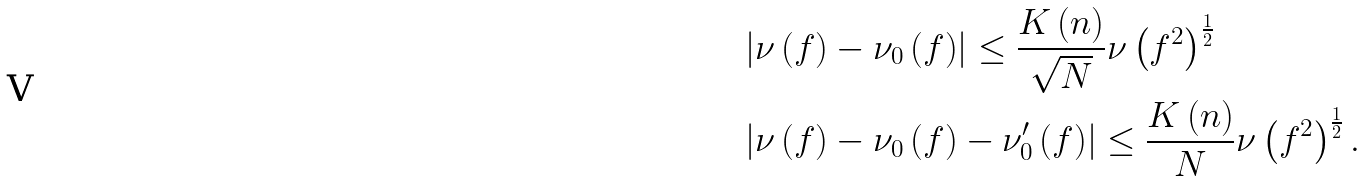<formula> <loc_0><loc_0><loc_500><loc_500>& \left | \nu \left ( f \right ) - \nu _ { 0 } \left ( f \right ) \right | \leq \frac { K \left ( n \right ) } { \sqrt { N } } \nu \left ( f ^ { 2 } \right ) ^ { \frac { 1 } { 2 } } \\ & \left | \nu \left ( f \right ) - \nu _ { 0 } \left ( f \right ) - \nu _ { 0 } ^ { \prime } \left ( f \right ) \right | \leq \frac { K \left ( n \right ) } { N } \nu \left ( f ^ { 2 } \right ) ^ { \frac { 1 } { 2 } } .</formula> 